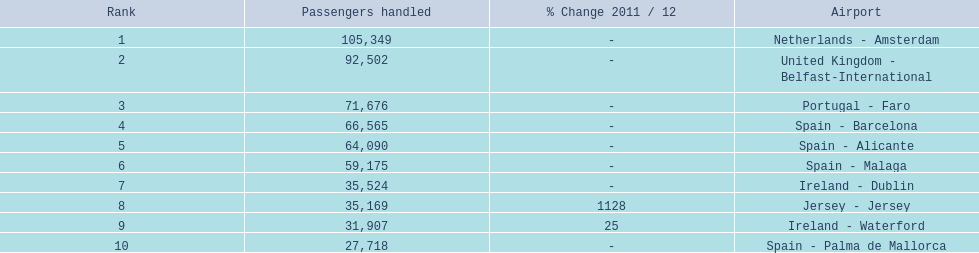What are all of the routes out of the london southend airport? Netherlands - Amsterdam, United Kingdom - Belfast-International, Portugal - Faro, Spain - Barcelona, Spain - Alicante, Spain - Malaga, Ireland - Dublin, Jersey - Jersey, Ireland - Waterford, Spain - Palma de Mallorca. How many passengers have traveled to each destination? 105,349, 92,502, 71,676, 66,565, 64,090, 59,175, 35,524, 35,169, 31,907, 27,718. Could you parse the entire table? {'header': ['Rank', 'Passengers handled', '% Change 2011 / 12', 'Airport'], 'rows': [['1', '105,349', '-', 'Netherlands - Amsterdam'], ['2', '92,502', '-', 'United Kingdom - Belfast-International'], ['3', '71,676', '-', 'Portugal - Faro'], ['4', '66,565', '-', 'Spain - Barcelona'], ['5', '64,090', '-', 'Spain - Alicante'], ['6', '59,175', '-', 'Spain - Malaga'], ['7', '35,524', '-', 'Ireland - Dublin'], ['8', '35,169', '1128', 'Jersey - Jersey'], ['9', '31,907', '25', 'Ireland - Waterford'], ['10', '27,718', '-', 'Spain - Palma de Mallorca']]} And which destination has been the most popular to passengers? Netherlands - Amsterdam. 